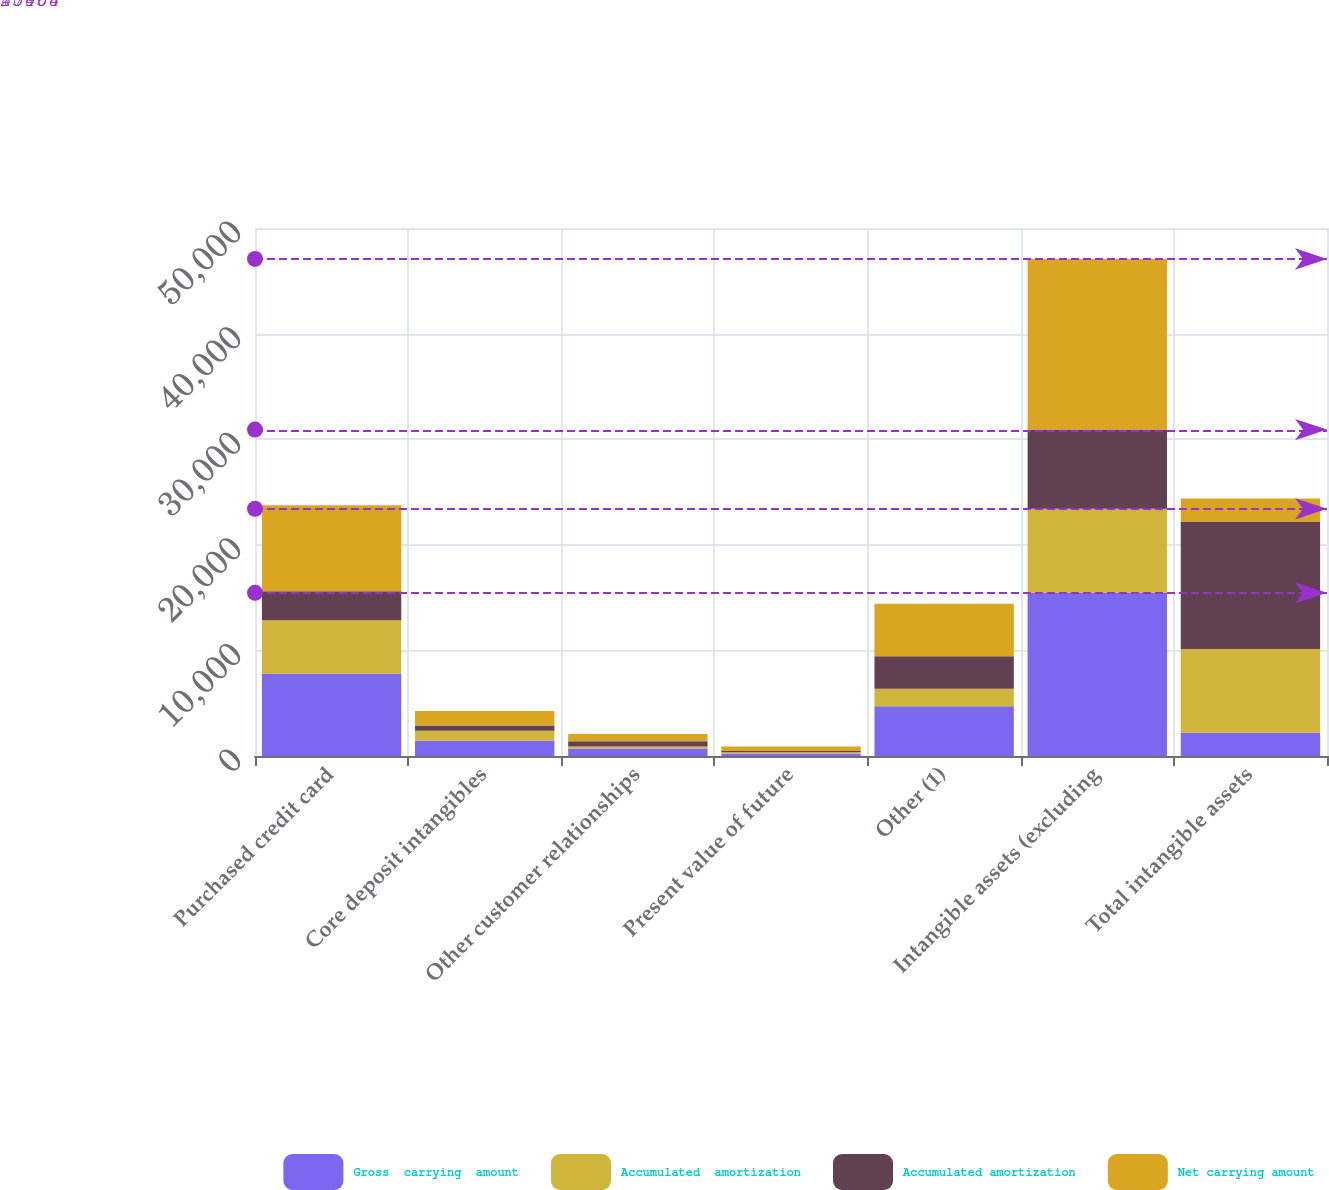<chart> <loc_0><loc_0><loc_500><loc_500><stacked_bar_chart><ecel><fcel>Purchased credit card<fcel>Core deposit intangibles<fcel>Other customer relationships<fcel>Present value of future<fcel>Other (1)<fcel>Intangible assets (excluding<fcel>Total intangible assets<nl><fcel>Gross  carrying  amount<fcel>7796<fcel>1442<fcel>702<fcel>241<fcel>4723<fcel>15454<fcel>2191<nl><fcel>Accumulated  amortization<fcel>5048<fcel>959<fcel>195<fcel>114<fcel>1634<fcel>7950<fcel>7950<nl><fcel>Accumulated amortization<fcel>2748<fcel>483<fcel>507<fcel>127<fcel>3089<fcel>7504<fcel>12058<nl><fcel>Net carrying amount<fcel>8148<fcel>1373<fcel>675<fcel>418<fcel>4977<fcel>16160<fcel>2191<nl></chart> 